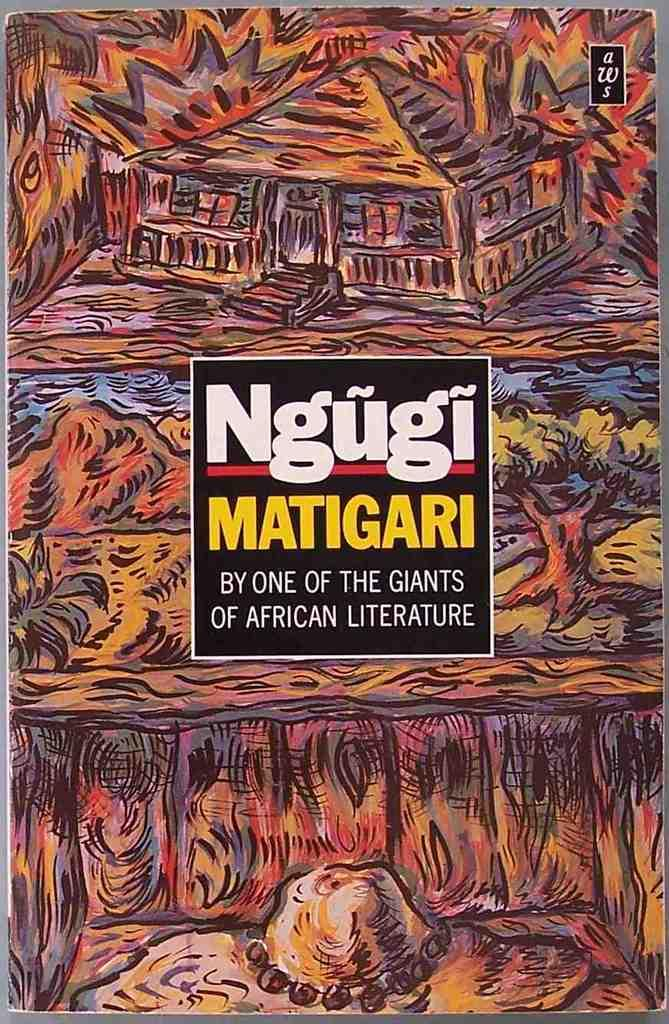<image>
Relay a brief, clear account of the picture shown. The colorful cover of Ngugi Matigari book displays African culture. 